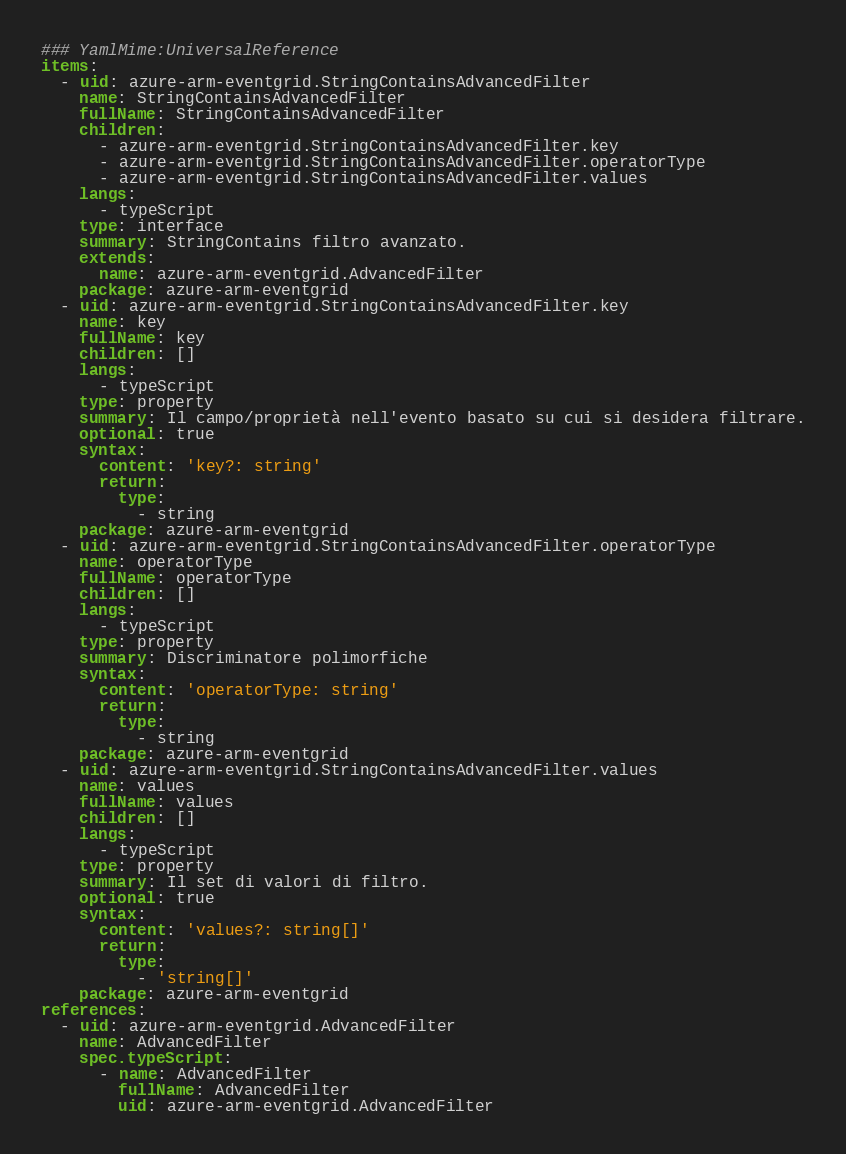<code> <loc_0><loc_0><loc_500><loc_500><_YAML_>### YamlMime:UniversalReference
items:
  - uid: azure-arm-eventgrid.StringContainsAdvancedFilter
    name: StringContainsAdvancedFilter
    fullName: StringContainsAdvancedFilter
    children:
      - azure-arm-eventgrid.StringContainsAdvancedFilter.key
      - azure-arm-eventgrid.StringContainsAdvancedFilter.operatorType
      - azure-arm-eventgrid.StringContainsAdvancedFilter.values
    langs:
      - typeScript
    type: interface
    summary: StringContains filtro avanzato.
    extends:
      name: azure-arm-eventgrid.AdvancedFilter
    package: azure-arm-eventgrid
  - uid: azure-arm-eventgrid.StringContainsAdvancedFilter.key
    name: key
    fullName: key
    children: []
    langs:
      - typeScript
    type: property
    summary: Il campo/proprietà nell'evento basato su cui si desidera filtrare.
    optional: true
    syntax:
      content: 'key?: string'
      return:
        type:
          - string
    package: azure-arm-eventgrid
  - uid: azure-arm-eventgrid.StringContainsAdvancedFilter.operatorType
    name: operatorType
    fullName: operatorType
    children: []
    langs:
      - typeScript
    type: property
    summary: Discriminatore polimorfiche
    syntax:
      content: 'operatorType: string'
      return:
        type:
          - string
    package: azure-arm-eventgrid
  - uid: azure-arm-eventgrid.StringContainsAdvancedFilter.values
    name: values
    fullName: values
    children: []
    langs:
      - typeScript
    type: property
    summary: Il set di valori di filtro.
    optional: true
    syntax:
      content: 'values?: string[]'
      return:
        type:
          - 'string[]'
    package: azure-arm-eventgrid
references:
  - uid: azure-arm-eventgrid.AdvancedFilter
    name: AdvancedFilter
    spec.typeScript:
      - name: AdvancedFilter
        fullName: AdvancedFilter
        uid: azure-arm-eventgrid.AdvancedFilter</code> 